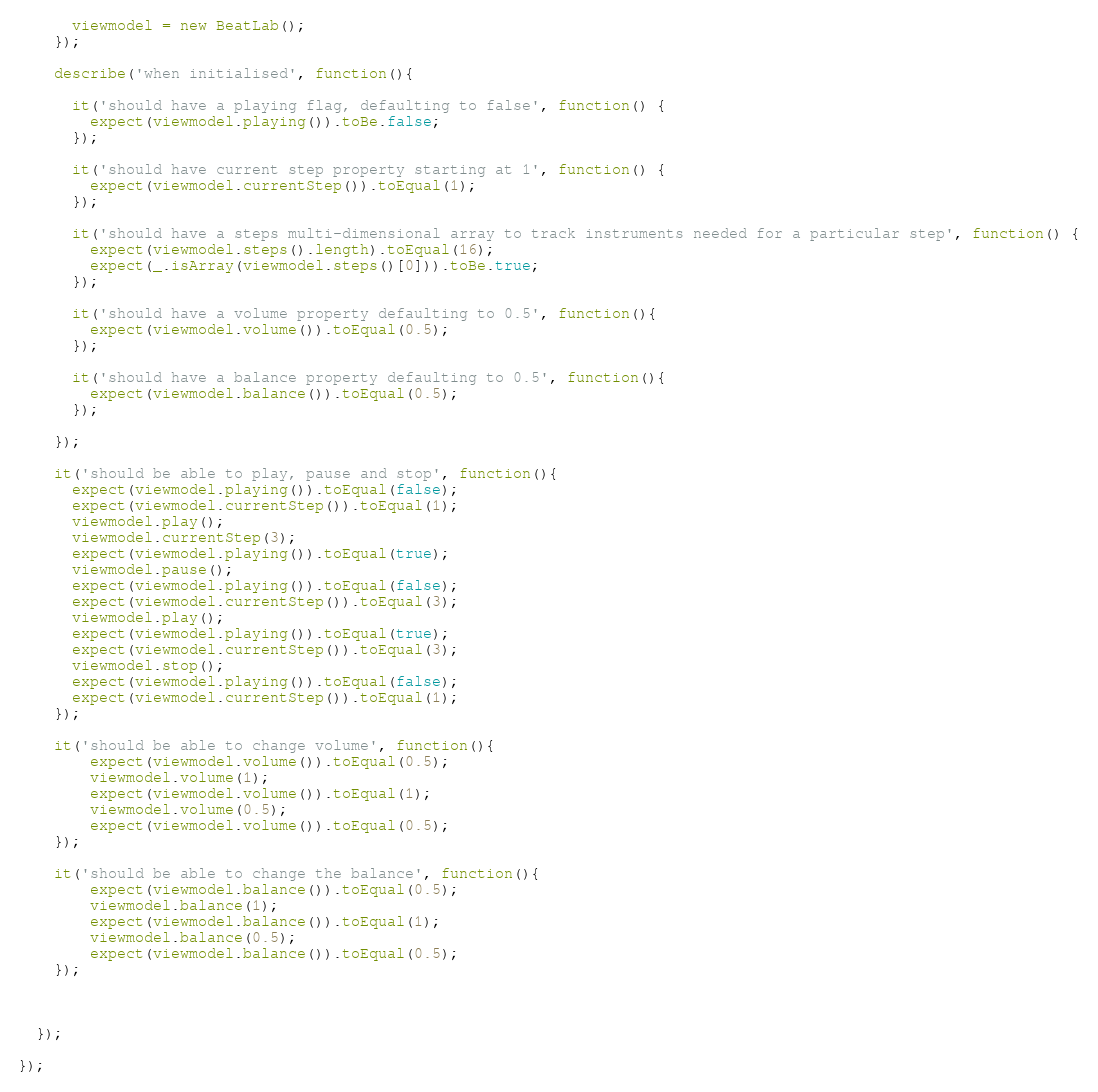Convert code to text. <code><loc_0><loc_0><loc_500><loc_500><_JavaScript_>      viewmodel = new BeatLab();
    });

    describe('when initialised', function(){
      
      it('should have a playing flag, defaulting to false', function() {
        expect(viewmodel.playing()).toBe.false;
      });

      it('should have current step property starting at 1', function() {
        expect(viewmodel.currentStep()).toEqual(1);
      });

      it('should have a steps multi-dimensional array to track instruments needed for a particular step', function() {
        expect(viewmodel.steps().length).toEqual(16);
        expect(_.isArray(viewmodel.steps()[0])).toBe.true;
      });

      it('should have a volume property defaulting to 0.5', function(){
        expect(viewmodel.volume()).toEqual(0.5);
      });

      it('should have a balance property defaulting to 0.5', function(){
        expect(viewmodel.balance()).toEqual(0.5);
      });

    });

    it('should be able to play, pause and stop', function(){
      expect(viewmodel.playing()).toEqual(false);
      expect(viewmodel.currentStep()).toEqual(1);
      viewmodel.play();
      viewmodel.currentStep(3);
      expect(viewmodel.playing()).toEqual(true);
      viewmodel.pause();
      expect(viewmodel.playing()).toEqual(false);
      expect(viewmodel.currentStep()).toEqual(3);
      viewmodel.play();
      expect(viewmodel.playing()).toEqual(true);
      expect(viewmodel.currentStep()).toEqual(3);
      viewmodel.stop();
      expect(viewmodel.playing()).toEqual(false);
      expect(viewmodel.currentStep()).toEqual(1);
    });

    it('should be able to change volume', function(){
        expect(viewmodel.volume()).toEqual(0.5);
        viewmodel.volume(1);
        expect(viewmodel.volume()).toEqual(1);
        viewmodel.volume(0.5);
        expect(viewmodel.volume()).toEqual(0.5);
    });

    it('should be able to change the balance', function(){
        expect(viewmodel.balance()).toEqual(0.5);
        viewmodel.balance(1);
        expect(viewmodel.balance()).toEqual(1);
        viewmodel.balance(0.5);
        expect(viewmodel.balance()).toEqual(0.5);
    });



  });

});</code> 